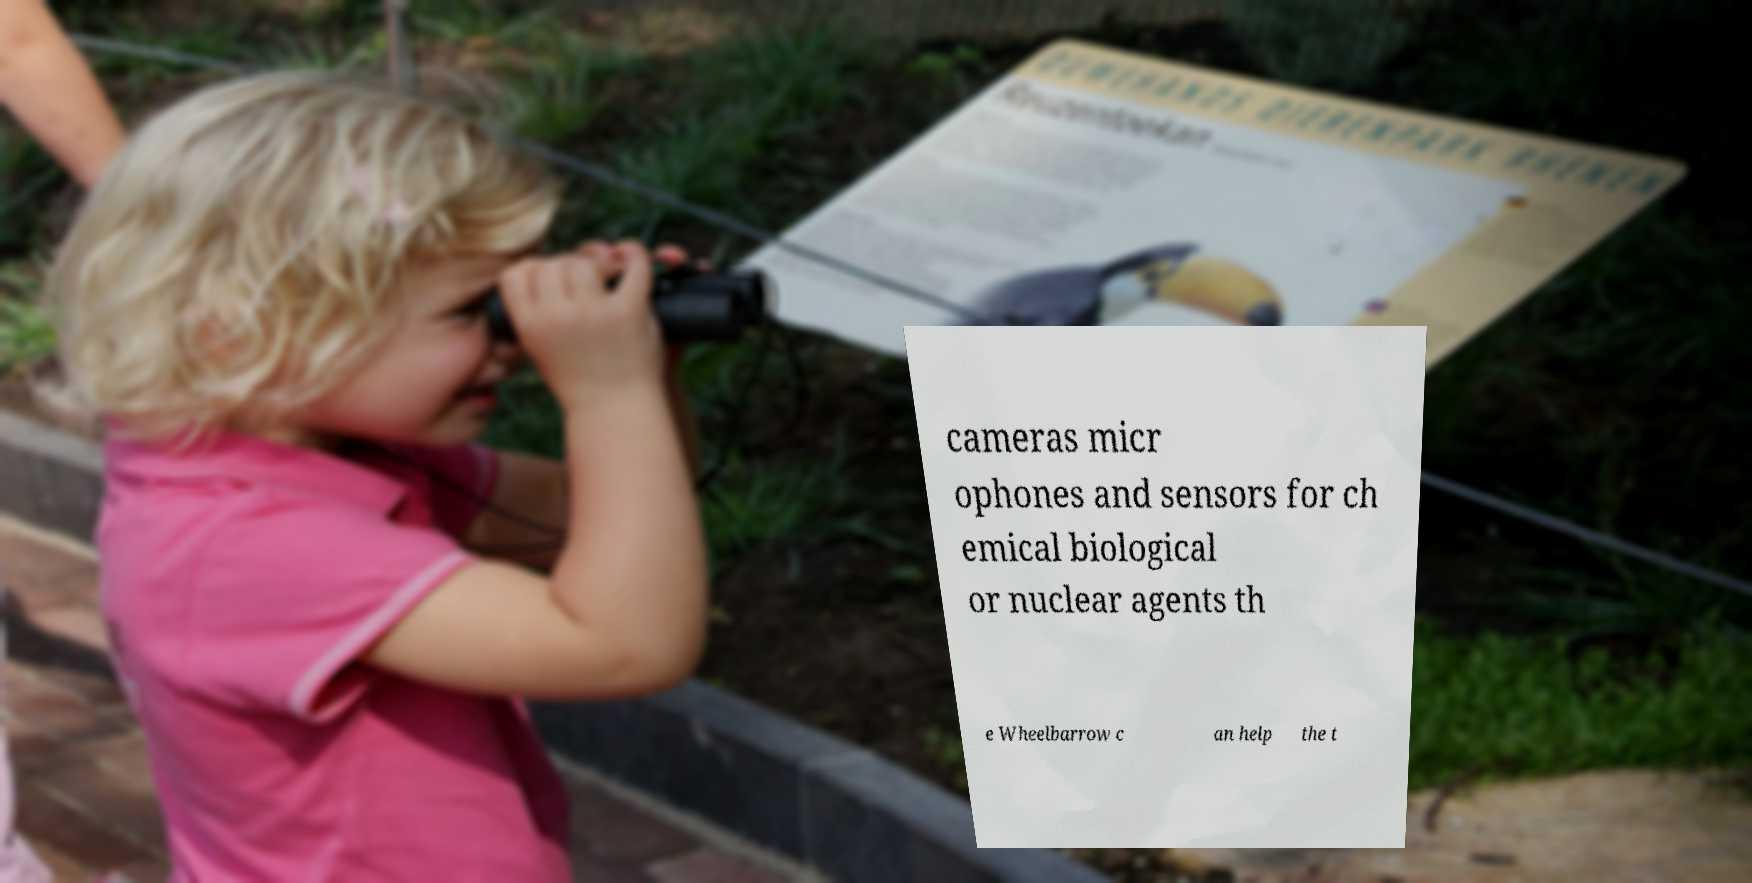Can you accurately transcribe the text from the provided image for me? cameras micr ophones and sensors for ch emical biological or nuclear agents th e Wheelbarrow c an help the t 